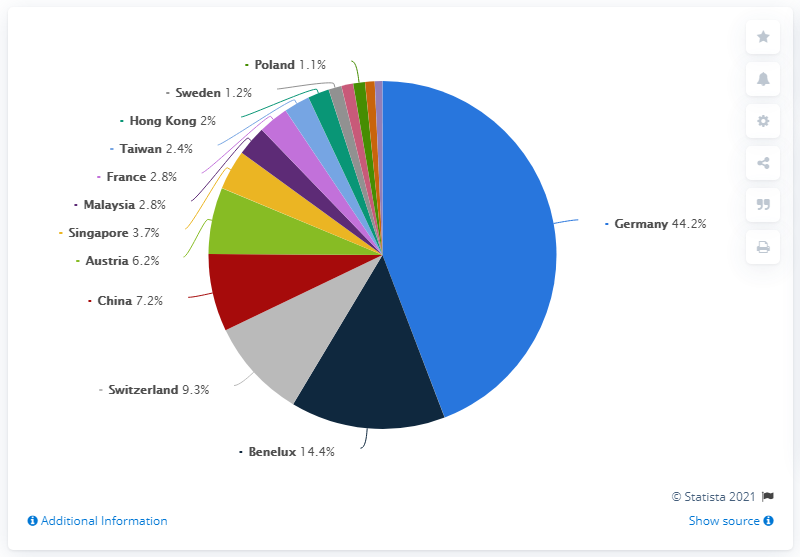List a handful of essential elements in this visual. The countries denoted by the purple, dark purple, and orange are France, Malaysia, and Singapore. The average of retail sales from Switzerland and Benelux is less than the retail sales of Germany. In fiscal year 2018/2019, approximately 7.2% of ESPRIT's total retail sales were generated in China. 